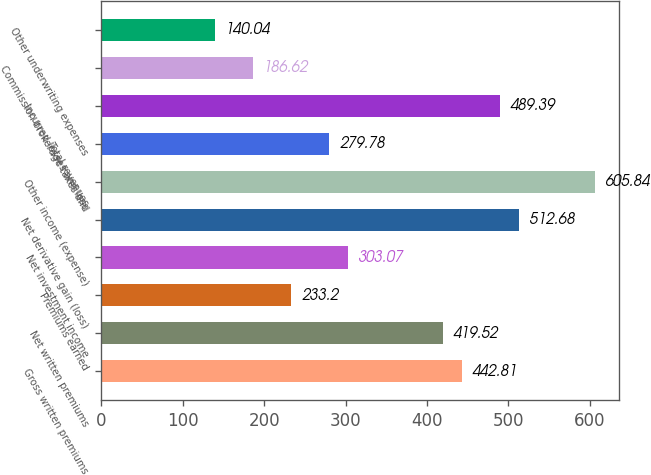<chart> <loc_0><loc_0><loc_500><loc_500><bar_chart><fcel>Gross written premiums<fcel>Net written premiums<fcel>Premiums earned<fcel>Net investment income<fcel>Net derivative gain (loss)<fcel>Other income (expense)<fcel>Total revenues<fcel>Incurred losses and loss<fcel>Commission brokerage taxes and<fcel>Other underwriting expenses<nl><fcel>442.81<fcel>419.52<fcel>233.2<fcel>303.07<fcel>512.68<fcel>605.84<fcel>279.78<fcel>489.39<fcel>186.62<fcel>140.04<nl></chart> 